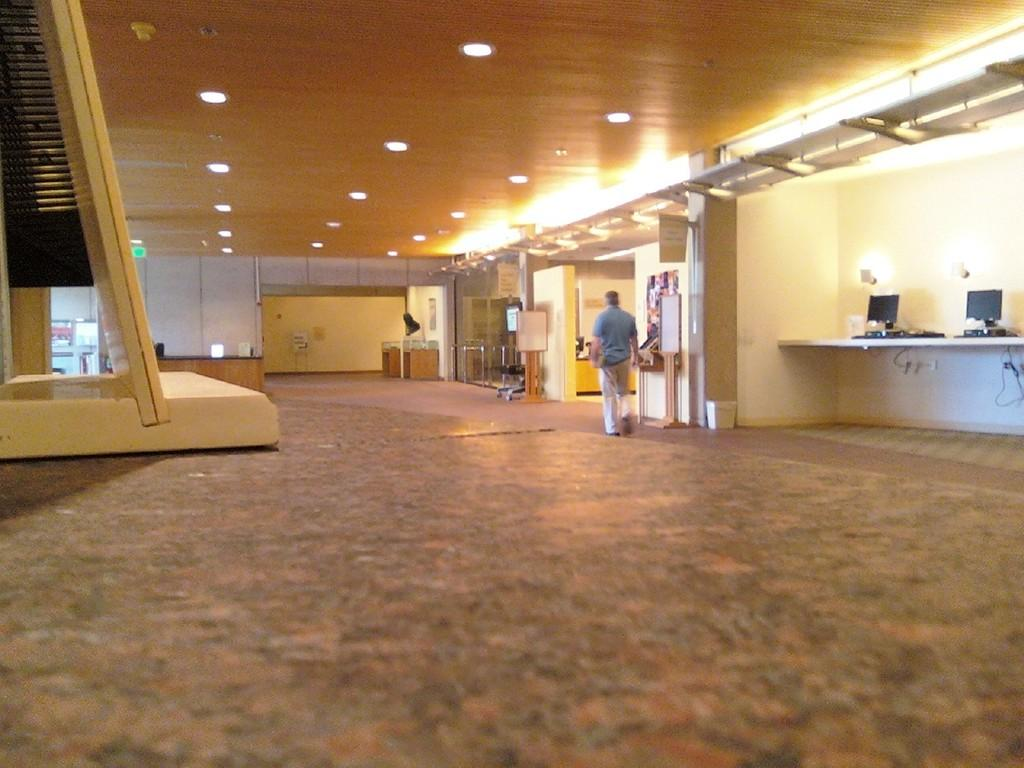What is the main subject in the image? There is a person standing in the image. What can be seen on the table in the image? There are monitors on a table in the image. What else is visible in the image besides the person and monitors? There are cables, lights, boards, and other unspecified objects visible in the image. What type of cheese is being used to cover the sheet in the image? There is no cheese or sheet present in the image. 